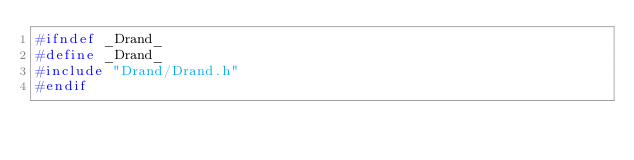<code> <loc_0><loc_0><loc_500><loc_500><_C_>#ifndef _Drand_
#define _Drand_
#include "Drand/Drand.h"
#endif
</code> 